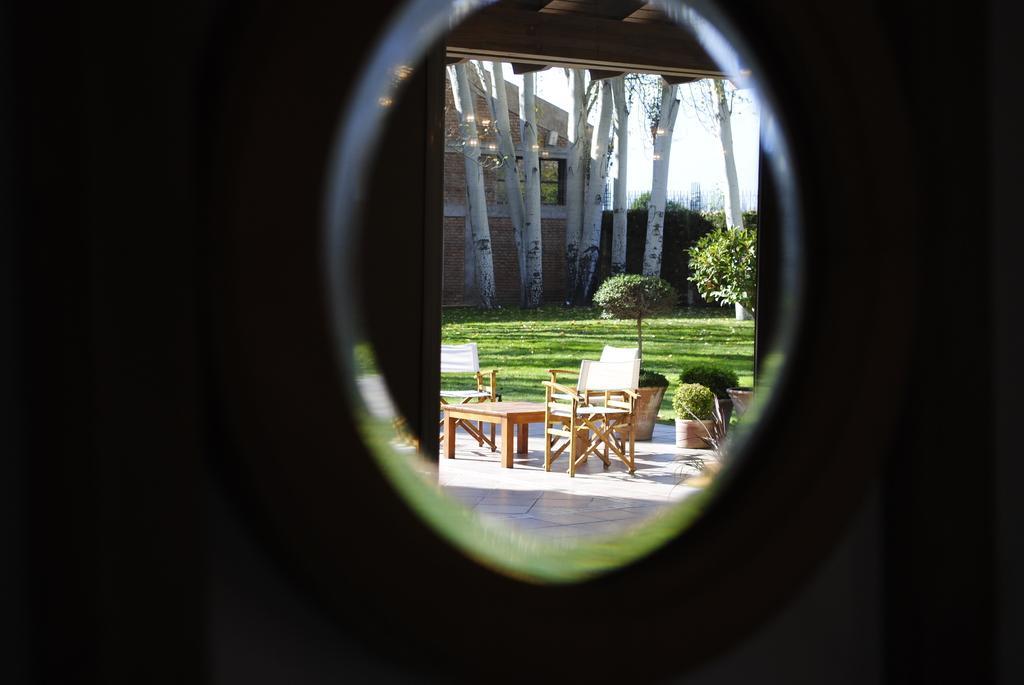How would you summarize this image in a sentence or two? In this image in the foreground there is one window, and in the background there is a table, chairs, flower pot, plants, trees and one house and in the center there is a grass. 